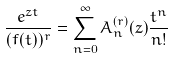Convert formula to latex. <formula><loc_0><loc_0><loc_500><loc_500>\frac { e ^ { z t } } { ( f ( t ) ) ^ { r } } = \sum _ { n = 0 } ^ { \infty } A _ { n } ^ { ( r ) } ( z ) \frac { t ^ { n } } { n ! }</formula> 